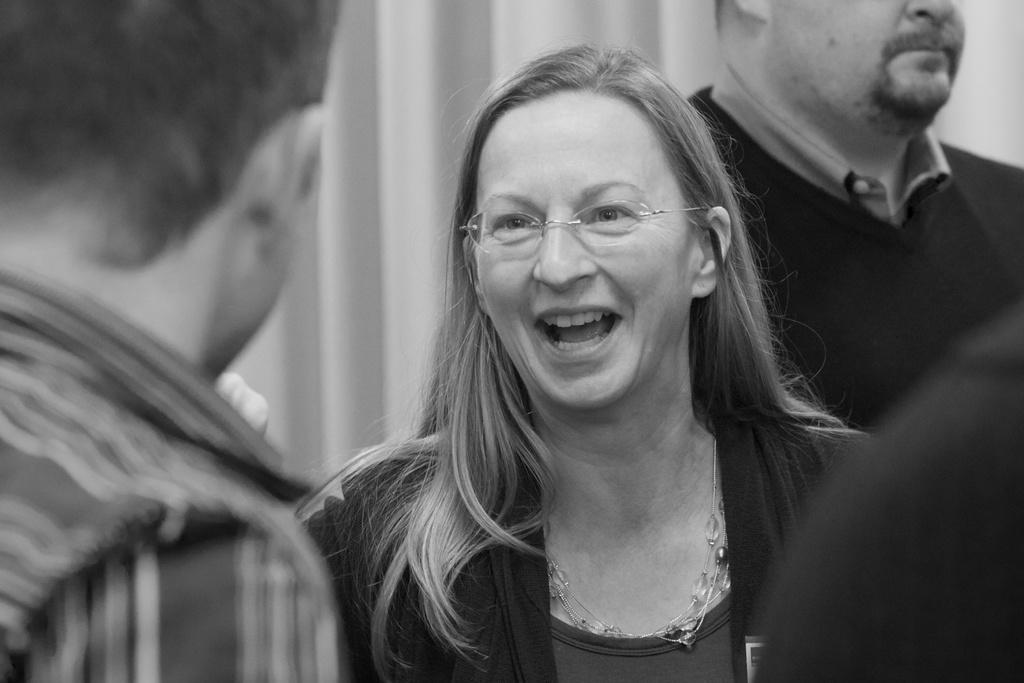Who is present in the image? There is a woman and two men in the image. What is the woman doing in the image? The woman is smiling in the image. What type of food is being prepared behind the curtain in the image? There is no curtain or food preparation visible in the image. Is there a tub in the image? No, there is no tub present in the image. 